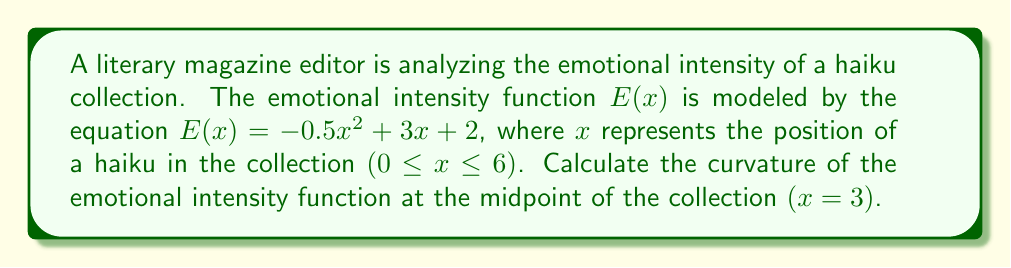Teach me how to tackle this problem. To find the curvature of the emotional intensity function, we'll follow these steps:

1) The formula for curvature $\kappa$ is:

   $$\kappa = \frac{|E''(x)|}{(1 + [E'(x)]^2)^{3/2}}$$

2) First, we need to find $E'(x)$ and $E''(x)$:
   
   $E'(x) = -x + 3$
   $E''(x) = -1$

3) At x = 3 (midpoint of the collection):
   
   $E'(3) = -3 + 3 = 0$
   $E''(3) = -1$

4) Now, let's substitute these values into the curvature formula:

   $$\kappa = \frac{|-1|}{(1 + [0]^2)^{3/2}}$$

5) Simplify:
   
   $$\kappa = \frac{1}{1^{3/2}} = 1$$

Therefore, the curvature of the emotional intensity function at the midpoint of the collection (x = 3) is 1.
Answer: 1 